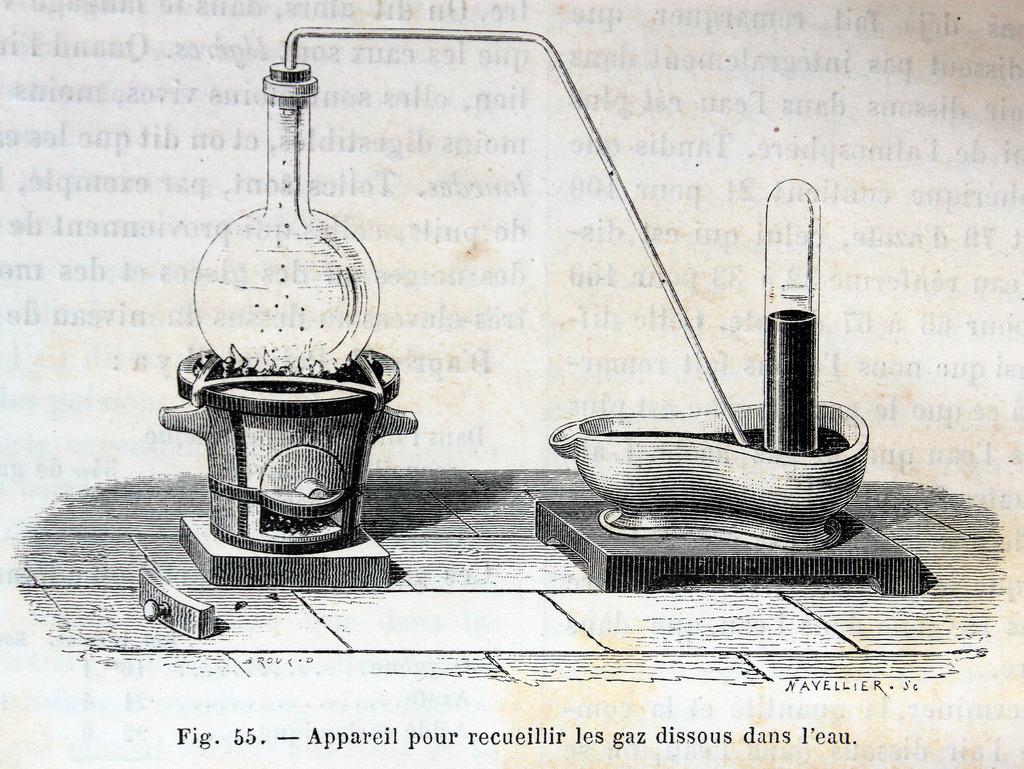What is figure 55?
Provide a short and direct response. Appareil pour recueillir les gaz dissous dans l'eau. What figure is this?
Give a very brief answer. 55. 